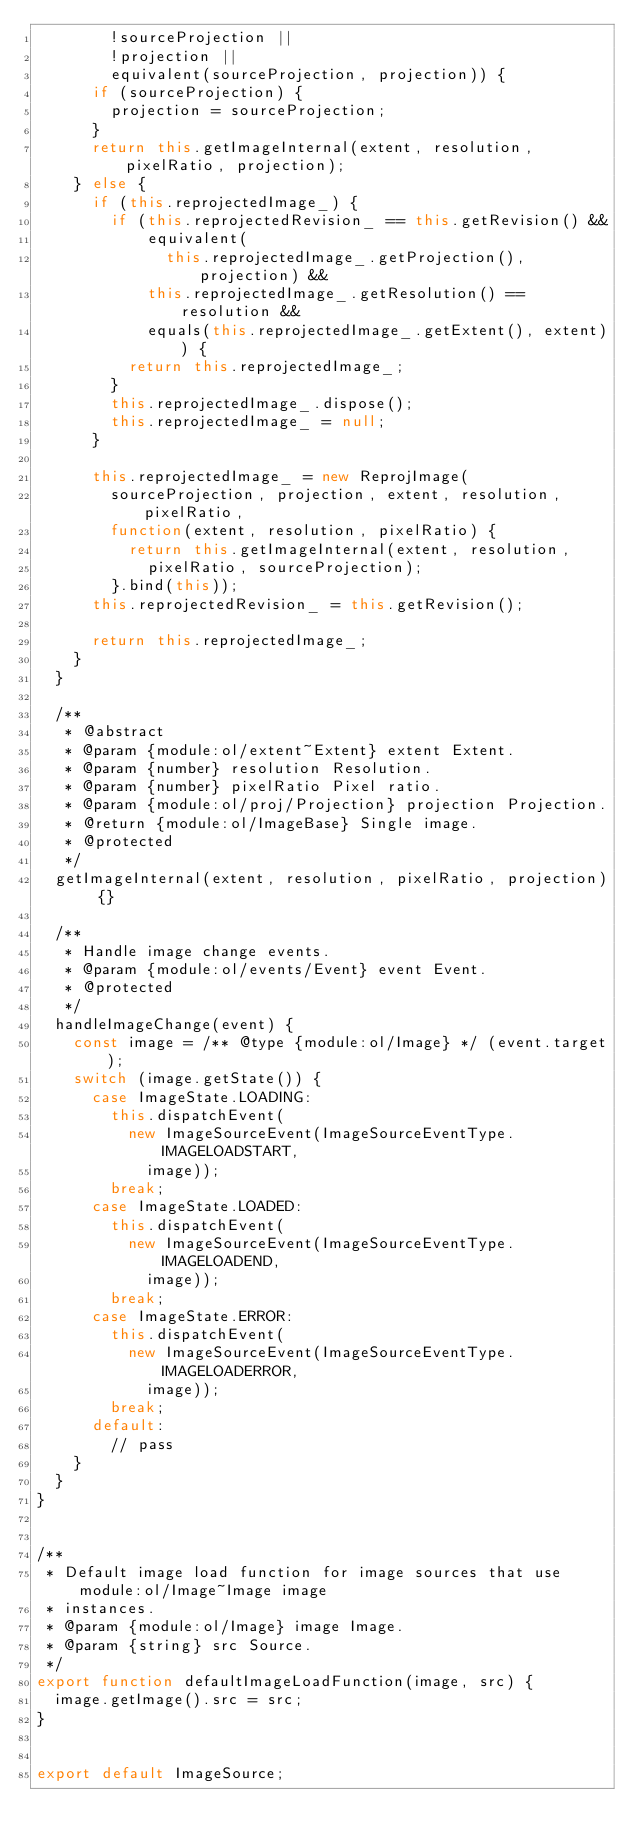Convert code to text. <code><loc_0><loc_0><loc_500><loc_500><_JavaScript_>        !sourceProjection ||
        !projection ||
        equivalent(sourceProjection, projection)) {
      if (sourceProjection) {
        projection = sourceProjection;
      }
      return this.getImageInternal(extent, resolution, pixelRatio, projection);
    } else {
      if (this.reprojectedImage_) {
        if (this.reprojectedRevision_ == this.getRevision() &&
            equivalent(
              this.reprojectedImage_.getProjection(), projection) &&
            this.reprojectedImage_.getResolution() == resolution &&
            equals(this.reprojectedImage_.getExtent(), extent)) {
          return this.reprojectedImage_;
        }
        this.reprojectedImage_.dispose();
        this.reprojectedImage_ = null;
      }

      this.reprojectedImage_ = new ReprojImage(
        sourceProjection, projection, extent, resolution, pixelRatio,
        function(extent, resolution, pixelRatio) {
          return this.getImageInternal(extent, resolution,
            pixelRatio, sourceProjection);
        }.bind(this));
      this.reprojectedRevision_ = this.getRevision();

      return this.reprojectedImage_;
    }
  }

  /**
   * @abstract
   * @param {module:ol/extent~Extent} extent Extent.
   * @param {number} resolution Resolution.
   * @param {number} pixelRatio Pixel ratio.
   * @param {module:ol/proj/Projection} projection Projection.
   * @return {module:ol/ImageBase} Single image.
   * @protected
   */
  getImageInternal(extent, resolution, pixelRatio, projection) {}

  /**
   * Handle image change events.
   * @param {module:ol/events/Event} event Event.
   * @protected
   */
  handleImageChange(event) {
    const image = /** @type {module:ol/Image} */ (event.target);
    switch (image.getState()) {
      case ImageState.LOADING:
        this.dispatchEvent(
          new ImageSourceEvent(ImageSourceEventType.IMAGELOADSTART,
            image));
        break;
      case ImageState.LOADED:
        this.dispatchEvent(
          new ImageSourceEvent(ImageSourceEventType.IMAGELOADEND,
            image));
        break;
      case ImageState.ERROR:
        this.dispatchEvent(
          new ImageSourceEvent(ImageSourceEventType.IMAGELOADERROR,
            image));
        break;
      default:
        // pass
    }
  }
}


/**
 * Default image load function for image sources that use module:ol/Image~Image image
 * instances.
 * @param {module:ol/Image} image Image.
 * @param {string} src Source.
 */
export function defaultImageLoadFunction(image, src) {
  image.getImage().src = src;
}


export default ImageSource;
</code> 